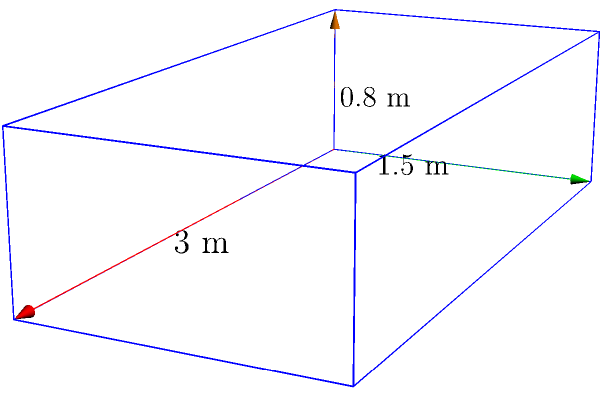A physiotherapy clinic needs to calculate the amount of antimicrobial fabric required to cover the lateral surface area of a new therapy table. The table has a rectangular prism shape with dimensions of 3 meters in length, 1.5 meters in width, and 0.8 meters in height. Calculate the lateral surface area of the table in square meters. To calculate the lateral surface area of a rectangular prism, we need to follow these steps:

1. Identify the lateral faces: These are the faces that are perpendicular to the base. In this case, there are four lateral faces.

2. Calculate the area of each lateral face:
   a. Front and back faces: $\text{length} \times \text{height} = 3 \text{ m} \times 0.8 \text{ m} = 2.4 \text{ m}^2$
   b. Left and right faces: $\text{width} \times \text{height} = 1.5 \text{ m} \times 0.8 \text{ m} = 1.2 \text{ m}^2$

3. Sum up the areas of all lateral faces:
   $\text{Lateral Surface Area} = 2(\text{front face}) + 2(\text{side face})$
   $= 2(2.4 \text{ m}^2) + 2(1.2 \text{ m}^2)$
   $= 4.8 \text{ m}^2 + 2.4 \text{ m}^2$
   $= 7.2 \text{ m}^2$

Therefore, the lateral surface area of the therapy table is 7.2 square meters.
Answer: 7.2 m² 